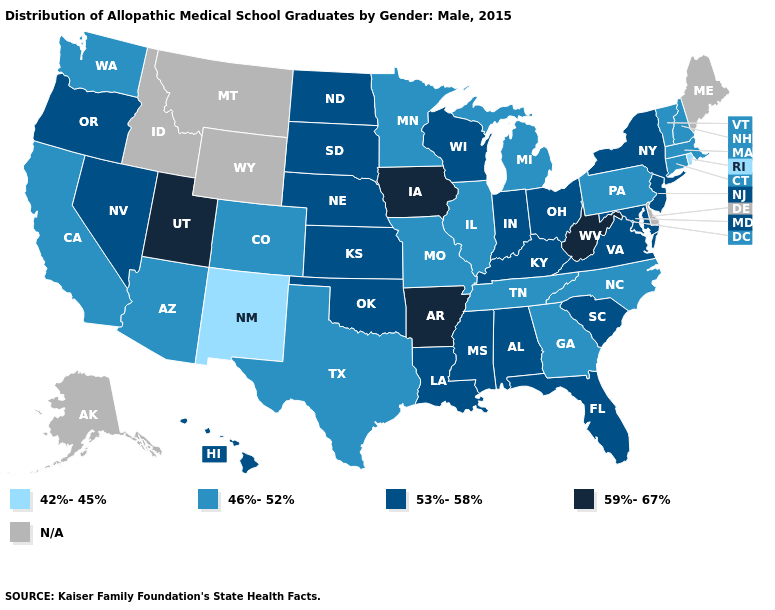How many symbols are there in the legend?
Quick response, please. 5. Name the states that have a value in the range N/A?
Answer briefly. Alaska, Delaware, Idaho, Maine, Montana, Wyoming. What is the value of Virginia?
Write a very short answer. 53%-58%. What is the lowest value in the South?
Write a very short answer. 46%-52%. Name the states that have a value in the range 59%-67%?
Be succinct. Arkansas, Iowa, Utah, West Virginia. What is the value of New Mexico?
Write a very short answer. 42%-45%. Among the states that border New York , which have the highest value?
Be succinct. New Jersey. Name the states that have a value in the range 46%-52%?
Be succinct. Arizona, California, Colorado, Connecticut, Georgia, Illinois, Massachusetts, Michigan, Minnesota, Missouri, New Hampshire, North Carolina, Pennsylvania, Tennessee, Texas, Vermont, Washington. What is the value of Iowa?
Short answer required. 59%-67%. What is the lowest value in states that border Pennsylvania?
Write a very short answer. 53%-58%. Does North Carolina have the lowest value in the South?
Concise answer only. Yes. How many symbols are there in the legend?
Keep it brief. 5. What is the value of Alabama?
Short answer required. 53%-58%. 